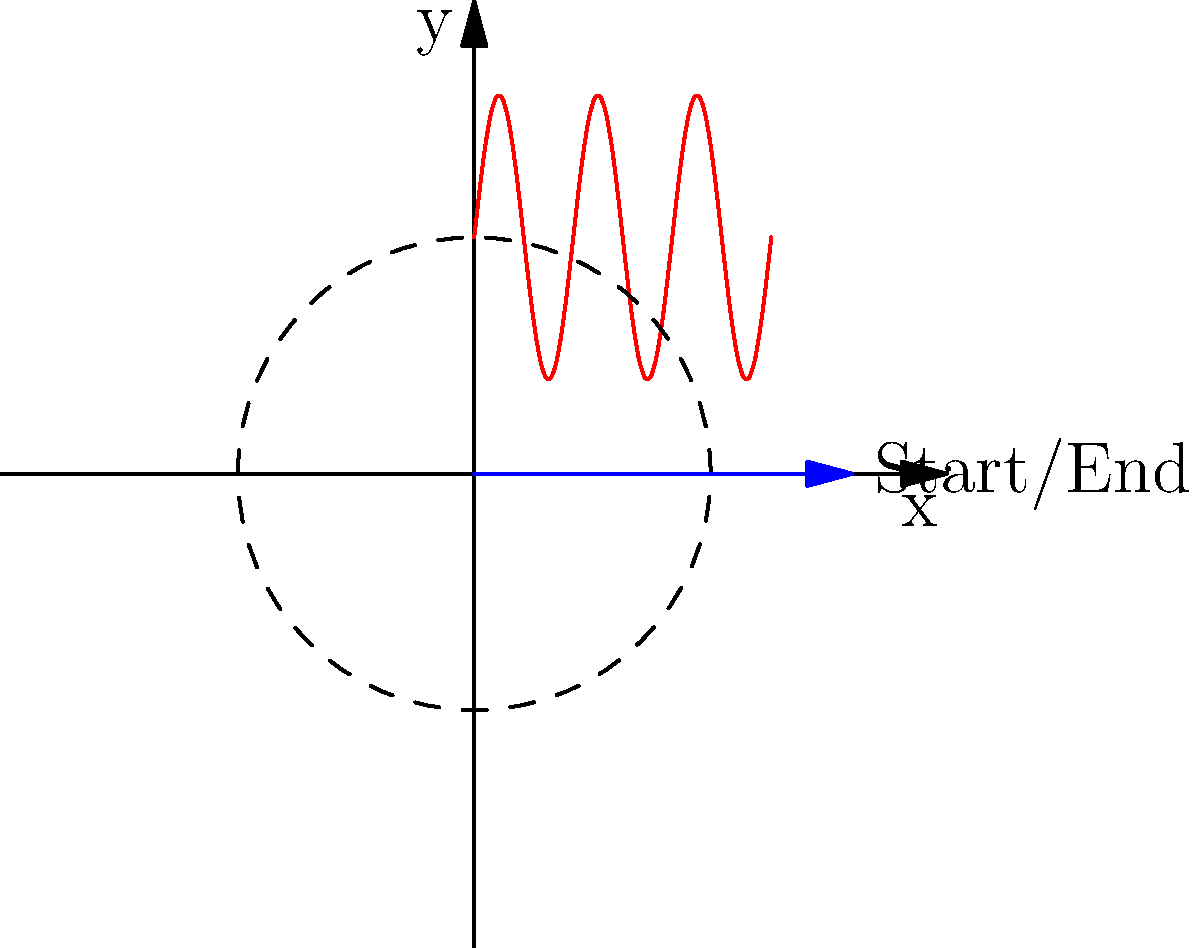A regular customer always follows the same path through the drive-thru, which can be described by the polar equation $r = 5 + 3\sin(3\theta)$. If the customer starts and ends their journey at the point $(8,0)$, how many times do they circle around the restaurant before completing their order? To solve this problem, let's follow these steps:

1) The equation $r = 5 + 3\sin(3\theta)$ describes a rose curve with 3 petals.

2) In polar coordinates, a complete revolution around the origin is represented by $\theta$ increasing by $2\pi$.

3) For this curve, when $\theta$ increases by $\frac{2\pi}{3}$, one petal is traced.

4) To complete the entire path, $\theta$ must increase by $2\pi$, which will trace all 3 petals.

5) The customer starts and ends at $(8,0)$, which corresponds to $\theta = 0$ and $\theta = 2\pi$ in polar coordinates.

6) During this journey from $\theta = 0$ to $\theta = 2\pi$, the curve makes one complete rotation around the origin.

Therefore, the customer circles around the restaurant exactly once before completing their order.
Answer: 1 time 